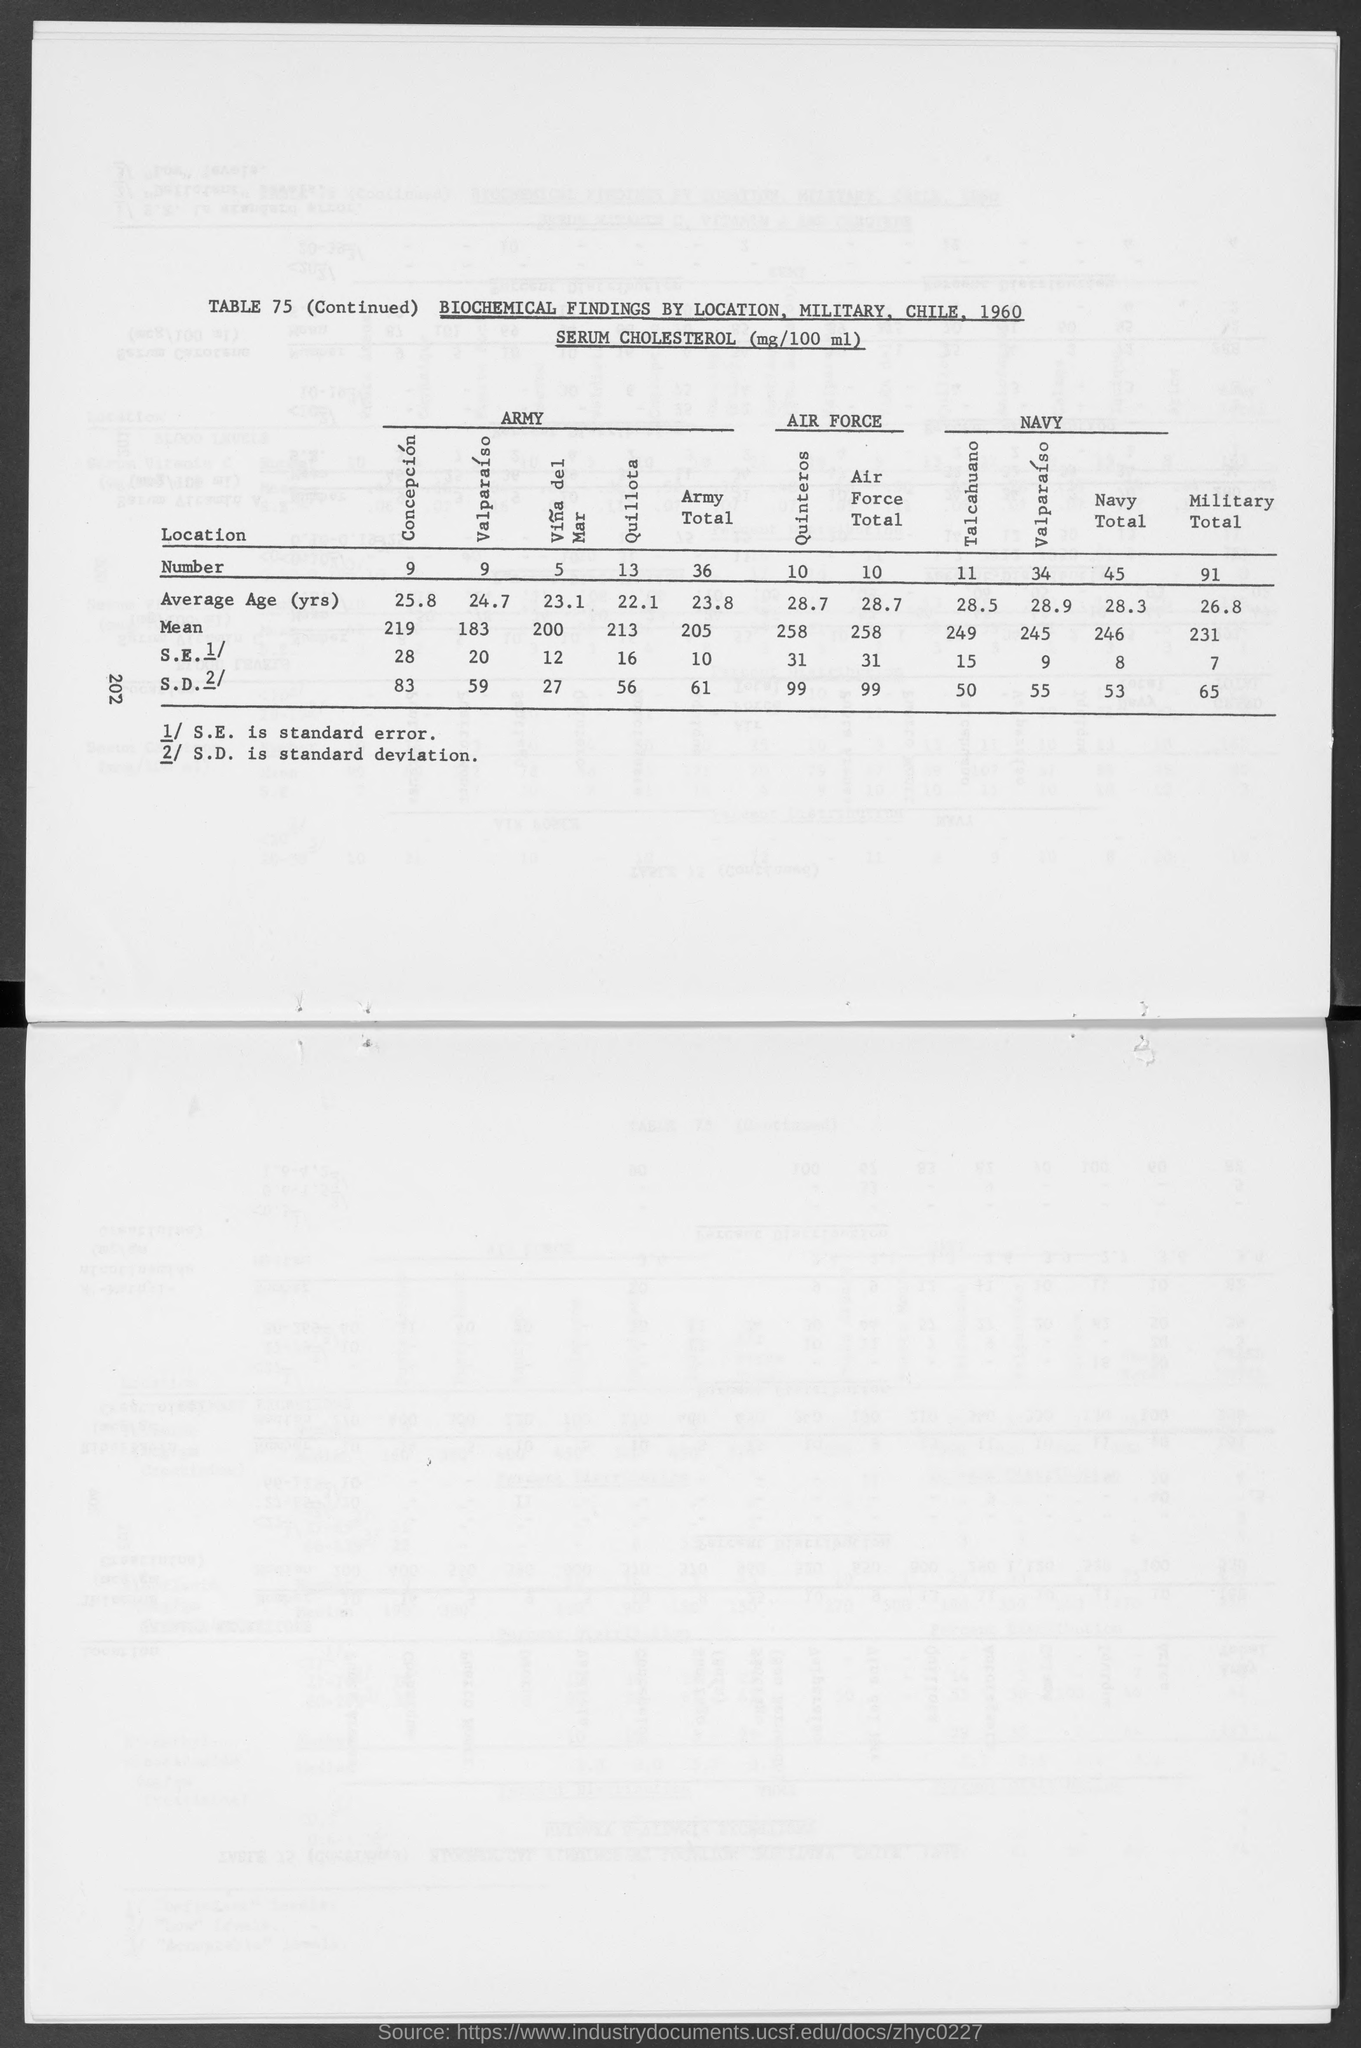Give some essential details in this illustration. The unit of serum cholesterol is milligrams per 100 milliliters. The abbreviation "S.E." generally stands for "standard error," which refers to the standard deviation of a statistic calculated from a sample of data, typically used to estimate a population parameter. Standard deviation is denoted by the abbreviation S.D. 